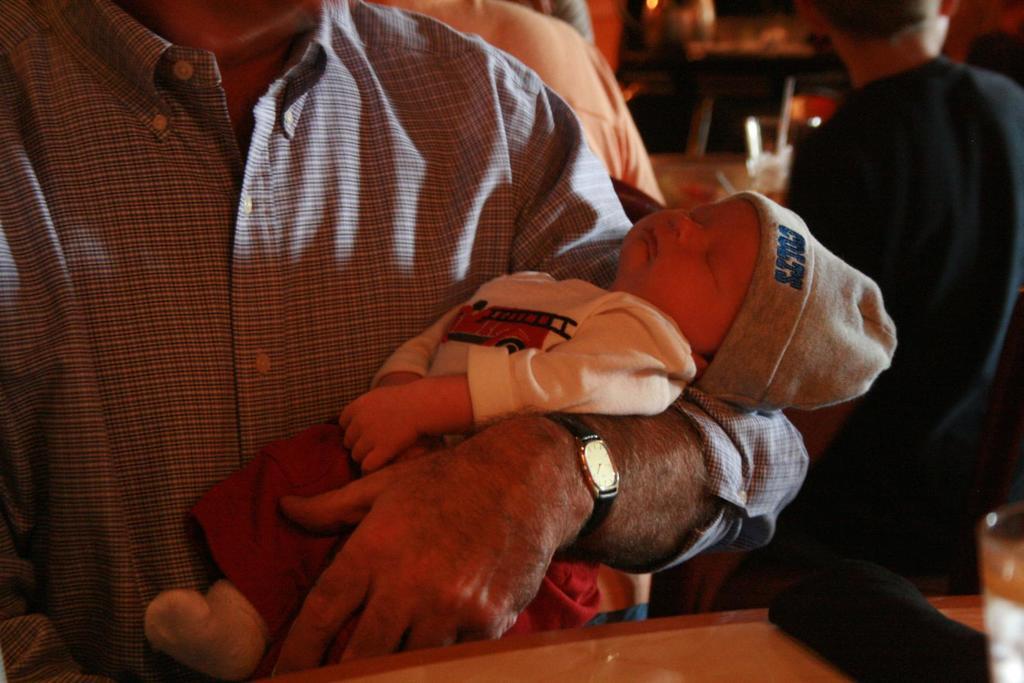What team does the baby support?
Your response must be concise. Colts. What does it say on the baby's hat?
Offer a very short reply. Colts. 